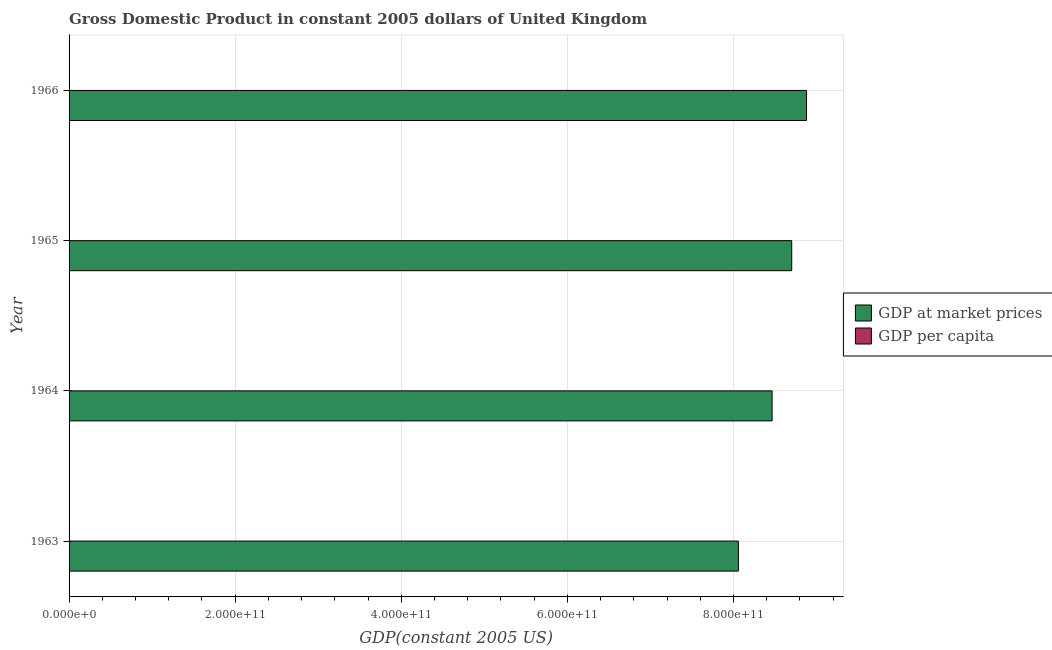How many different coloured bars are there?
Ensure brevity in your answer.  2. How many groups of bars are there?
Your answer should be very brief. 4. Are the number of bars per tick equal to the number of legend labels?
Your response must be concise. Yes. How many bars are there on the 4th tick from the top?
Offer a very short reply. 2. How many bars are there on the 4th tick from the bottom?
Provide a short and direct response. 2. What is the gdp per capita in 1966?
Your answer should be compact. 1.62e+04. Across all years, what is the maximum gdp at market prices?
Your response must be concise. 8.88e+11. Across all years, what is the minimum gdp at market prices?
Keep it short and to the point. 8.06e+11. In which year was the gdp at market prices maximum?
Your response must be concise. 1966. What is the total gdp at market prices in the graph?
Your answer should be compact. 3.41e+12. What is the difference between the gdp per capita in 1963 and that in 1966?
Offer a terse response. -1226.79. What is the difference between the gdp at market prices in 1966 and the gdp per capita in 1965?
Offer a very short reply. 8.88e+11. What is the average gdp at market prices per year?
Your response must be concise. 8.53e+11. In the year 1965, what is the difference between the gdp per capita and gdp at market prices?
Give a very brief answer. -8.70e+11. What is the ratio of the gdp per capita in 1963 to that in 1966?
Your answer should be very brief. 0.92. What is the difference between the highest and the second highest gdp per capita?
Your answer should be compact. 238.26. What is the difference between the highest and the lowest gdp at market prices?
Keep it short and to the point. 8.20e+1. In how many years, is the gdp per capita greater than the average gdp per capita taken over all years?
Your answer should be very brief. 2. Is the sum of the gdp at market prices in 1964 and 1966 greater than the maximum gdp per capita across all years?
Offer a terse response. Yes. What does the 2nd bar from the top in 1963 represents?
Ensure brevity in your answer.  GDP at market prices. What does the 2nd bar from the bottom in 1963 represents?
Your answer should be very brief. GDP per capita. How many years are there in the graph?
Make the answer very short. 4. What is the difference between two consecutive major ticks on the X-axis?
Offer a very short reply. 2.00e+11. Does the graph contain any zero values?
Provide a short and direct response. No. Does the graph contain grids?
Offer a terse response. Yes. What is the title of the graph?
Your answer should be very brief. Gross Domestic Product in constant 2005 dollars of United Kingdom. Does "International Visitors" appear as one of the legend labels in the graph?
Keep it short and to the point. No. What is the label or title of the X-axis?
Provide a succinct answer. GDP(constant 2005 US). What is the GDP(constant 2005 US) in GDP at market prices in 1963?
Give a very brief answer. 8.06e+11. What is the GDP(constant 2005 US) of GDP per capita in 1963?
Ensure brevity in your answer.  1.50e+04. What is the GDP(constant 2005 US) of GDP at market prices in 1964?
Your answer should be compact. 8.46e+11. What is the GDP(constant 2005 US) of GDP per capita in 1964?
Offer a terse response. 1.57e+04. What is the GDP(constant 2005 US) in GDP at market prices in 1965?
Give a very brief answer. 8.70e+11. What is the GDP(constant 2005 US) in GDP per capita in 1965?
Make the answer very short. 1.60e+04. What is the GDP(constant 2005 US) in GDP at market prices in 1966?
Give a very brief answer. 8.88e+11. What is the GDP(constant 2005 US) of GDP per capita in 1966?
Your response must be concise. 1.62e+04. Across all years, what is the maximum GDP(constant 2005 US) in GDP at market prices?
Give a very brief answer. 8.88e+11. Across all years, what is the maximum GDP(constant 2005 US) of GDP per capita?
Ensure brevity in your answer.  1.62e+04. Across all years, what is the minimum GDP(constant 2005 US) in GDP at market prices?
Offer a terse response. 8.06e+11. Across all years, what is the minimum GDP(constant 2005 US) of GDP per capita?
Your answer should be very brief. 1.50e+04. What is the total GDP(constant 2005 US) of GDP at market prices in the graph?
Your answer should be very brief. 3.41e+12. What is the total GDP(constant 2005 US) in GDP per capita in the graph?
Keep it short and to the point. 6.30e+04. What is the difference between the GDP(constant 2005 US) of GDP at market prices in 1963 and that in 1964?
Your answer should be very brief. -4.06e+1. What is the difference between the GDP(constant 2005 US) in GDP per capita in 1963 and that in 1964?
Provide a succinct answer. -654.53. What is the difference between the GDP(constant 2005 US) of GDP at market prices in 1963 and that in 1965?
Your answer should be very brief. -6.42e+1. What is the difference between the GDP(constant 2005 US) of GDP per capita in 1963 and that in 1965?
Give a very brief answer. -988.53. What is the difference between the GDP(constant 2005 US) of GDP at market prices in 1963 and that in 1966?
Give a very brief answer. -8.20e+1. What is the difference between the GDP(constant 2005 US) of GDP per capita in 1963 and that in 1966?
Offer a very short reply. -1226.79. What is the difference between the GDP(constant 2005 US) of GDP at market prices in 1964 and that in 1965?
Keep it short and to the point. -2.36e+1. What is the difference between the GDP(constant 2005 US) in GDP per capita in 1964 and that in 1965?
Offer a very short reply. -334. What is the difference between the GDP(constant 2005 US) in GDP at market prices in 1964 and that in 1966?
Your response must be concise. -4.14e+1. What is the difference between the GDP(constant 2005 US) of GDP per capita in 1964 and that in 1966?
Provide a short and direct response. -572.26. What is the difference between the GDP(constant 2005 US) of GDP at market prices in 1965 and that in 1966?
Provide a short and direct response. -1.78e+1. What is the difference between the GDP(constant 2005 US) of GDP per capita in 1965 and that in 1966?
Your answer should be very brief. -238.26. What is the difference between the GDP(constant 2005 US) of GDP at market prices in 1963 and the GDP(constant 2005 US) of GDP per capita in 1964?
Ensure brevity in your answer.  8.06e+11. What is the difference between the GDP(constant 2005 US) in GDP at market prices in 1963 and the GDP(constant 2005 US) in GDP per capita in 1965?
Provide a short and direct response. 8.06e+11. What is the difference between the GDP(constant 2005 US) in GDP at market prices in 1963 and the GDP(constant 2005 US) in GDP per capita in 1966?
Offer a very short reply. 8.06e+11. What is the difference between the GDP(constant 2005 US) of GDP at market prices in 1964 and the GDP(constant 2005 US) of GDP per capita in 1965?
Your response must be concise. 8.46e+11. What is the difference between the GDP(constant 2005 US) in GDP at market prices in 1964 and the GDP(constant 2005 US) in GDP per capita in 1966?
Offer a very short reply. 8.46e+11. What is the difference between the GDP(constant 2005 US) in GDP at market prices in 1965 and the GDP(constant 2005 US) in GDP per capita in 1966?
Your answer should be very brief. 8.70e+11. What is the average GDP(constant 2005 US) in GDP at market prices per year?
Your answer should be compact. 8.53e+11. What is the average GDP(constant 2005 US) of GDP per capita per year?
Give a very brief answer. 1.57e+04. In the year 1963, what is the difference between the GDP(constant 2005 US) in GDP at market prices and GDP(constant 2005 US) in GDP per capita?
Give a very brief answer. 8.06e+11. In the year 1964, what is the difference between the GDP(constant 2005 US) of GDP at market prices and GDP(constant 2005 US) of GDP per capita?
Your response must be concise. 8.46e+11. In the year 1965, what is the difference between the GDP(constant 2005 US) of GDP at market prices and GDP(constant 2005 US) of GDP per capita?
Provide a short and direct response. 8.70e+11. In the year 1966, what is the difference between the GDP(constant 2005 US) of GDP at market prices and GDP(constant 2005 US) of GDP per capita?
Make the answer very short. 8.88e+11. What is the ratio of the GDP(constant 2005 US) of GDP at market prices in 1963 to that in 1964?
Make the answer very short. 0.95. What is the ratio of the GDP(constant 2005 US) in GDP per capita in 1963 to that in 1964?
Provide a succinct answer. 0.96. What is the ratio of the GDP(constant 2005 US) in GDP at market prices in 1963 to that in 1965?
Keep it short and to the point. 0.93. What is the ratio of the GDP(constant 2005 US) of GDP per capita in 1963 to that in 1965?
Provide a succinct answer. 0.94. What is the ratio of the GDP(constant 2005 US) of GDP at market prices in 1963 to that in 1966?
Your answer should be compact. 0.91. What is the ratio of the GDP(constant 2005 US) of GDP per capita in 1963 to that in 1966?
Offer a very short reply. 0.92. What is the ratio of the GDP(constant 2005 US) of GDP at market prices in 1964 to that in 1965?
Provide a succinct answer. 0.97. What is the ratio of the GDP(constant 2005 US) in GDP per capita in 1964 to that in 1965?
Give a very brief answer. 0.98. What is the ratio of the GDP(constant 2005 US) of GDP at market prices in 1964 to that in 1966?
Keep it short and to the point. 0.95. What is the ratio of the GDP(constant 2005 US) of GDP per capita in 1964 to that in 1966?
Make the answer very short. 0.96. What is the ratio of the GDP(constant 2005 US) in GDP at market prices in 1965 to that in 1966?
Provide a succinct answer. 0.98. What is the ratio of the GDP(constant 2005 US) in GDP per capita in 1965 to that in 1966?
Keep it short and to the point. 0.99. What is the difference between the highest and the second highest GDP(constant 2005 US) of GDP at market prices?
Your response must be concise. 1.78e+1. What is the difference between the highest and the second highest GDP(constant 2005 US) in GDP per capita?
Give a very brief answer. 238.26. What is the difference between the highest and the lowest GDP(constant 2005 US) in GDP at market prices?
Ensure brevity in your answer.  8.20e+1. What is the difference between the highest and the lowest GDP(constant 2005 US) in GDP per capita?
Your answer should be very brief. 1226.79. 